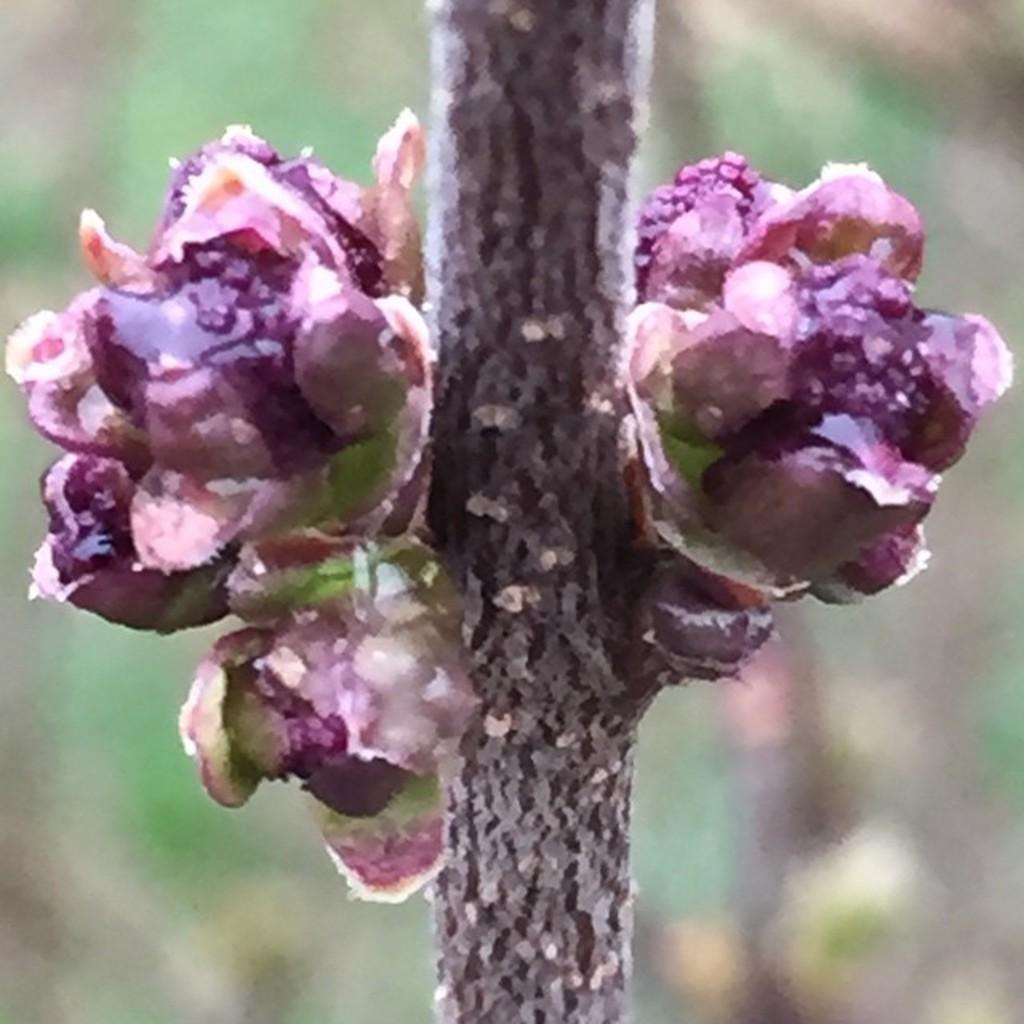Describe this image in one or two sentences. In this image, we can see some flowers with stem. Background there is a blur view. 